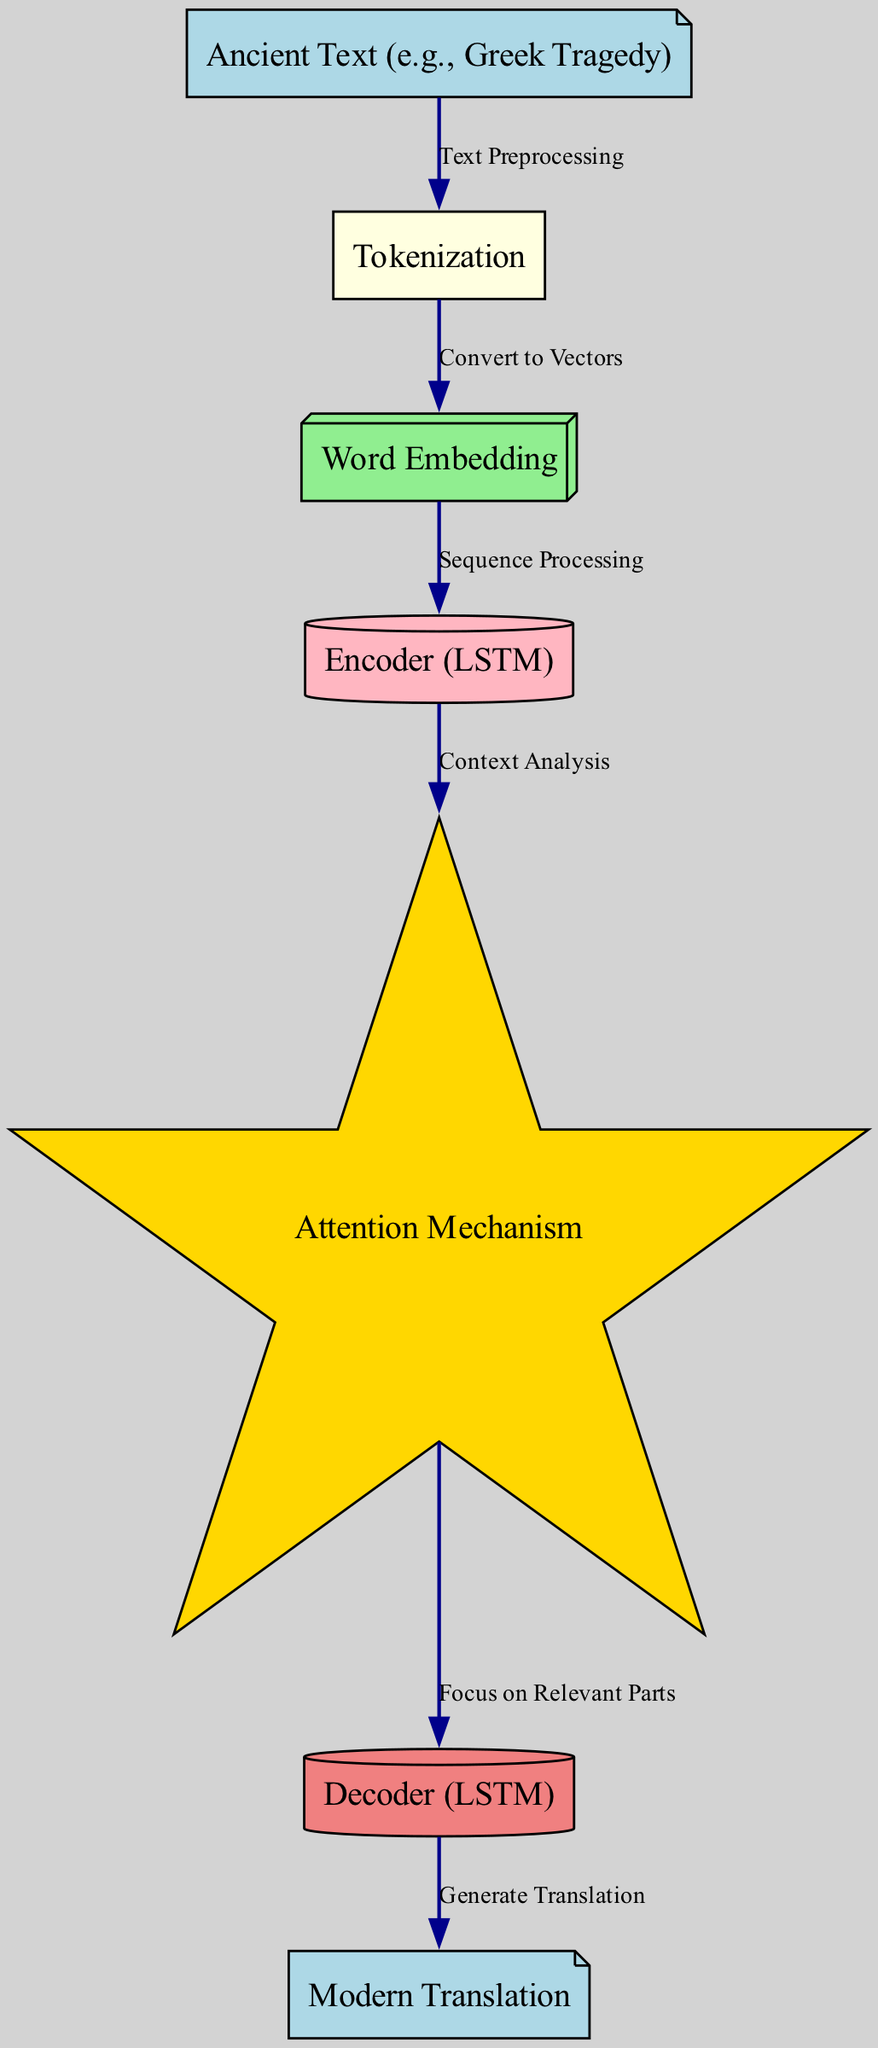What is the input of the diagram? The input node is labeled "Ancient Text (e.g., Greek Tragedy)", which indicates that this is the starting point of the translation process.
Answer: Ancient Text (e.g., Greek Tragedy) How many nodes are present in the diagram? The diagram includes a total of 7 nodes, as indicated in the provided data. These nodes represent various stages in the translation process.
Answer: 7 What does the attention mechanism focus on? The edge between the "Attention Mechanism" and "Decoder (LSTM)" is labeled "Focus on Relevant Parts", which defines the function of this component in the diagram.
Answer: Relevant Parts What is the final output of the translation process? The last node labeled "Modern Translation" serves as the final output of the neural network's operation.
Answer: Modern Translation What relationship exists between tokenization and word embedding? The edge connecting "Tokenization" to "Word Embedding" is labeled "Convert to Vectors", illustrating the transformation from tokenized text to vector representations.
Answer: Convert to Vectors What type of neural network is used for encoding? The node labeled "Encoder (LSTM)" specifies that an LSTM (Long Short-Term Memory) neural network is utilized for encoding the input sequences.
Answer: LSTM How does the decoder generate the translation? The edge connecting the "Decoder (LSTM)" to "Modern Translation" is labeled "Generate Translation", indicating the decoder's role in producing the translated output.
Answer: Generate Translation What analysis occurs after the encoder processes the input? The edge from "Encoder (LSTM)" to "Attention Mechanism" is labeled "Context Analysis", which describes the analysis performed to inform the decoder.
Answer: Context Analysis What step comes after word embedding in the diagram? The flow in the diagram shows that "Word Embedding" leads to "Encoder (LSTM)", indicating that the next step after embedding is sequence processing by the encoder.
Answer: Encoder (LSTM) 